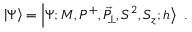<formula> <loc_0><loc_0><loc_500><loc_500>\left | \Psi \right \rangle = \left | \Psi ; M , P ^ { + } , \vec { P } _ { \, \perp } , S ^ { 2 } , S _ { z } ; h \right \rangle \ .</formula> 